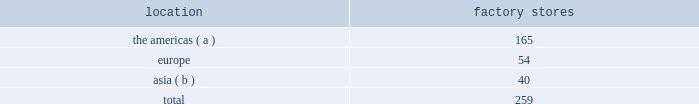Factory stores we extend our reach to additional consumer groups through our 259 factory stores worldwide , which are principally located in major outlet centers .
During fiscal 2015 , we added 30 new factory stores and closed six factory stores .
We operated the following factory stores as of march 28 , 2015: .
( a ) includes the u.s .
And canada .
( b ) includes australia .
Our worldwide factory stores offer selections of our apparel , accessories , and fragrances .
In addition to these product offerings , certain of our factory stores in the americas offer home furnishings .
Our factory stores range in size from approximately 800 to 26700 square feet .
Factory stores obtain products from our suppliers , our product licensing partners , and our other retail stores and e-commerce operations , and also serve as a secondary distribution channel for our excess and out-of-season products .
Concession-based shop-within-shops the terms of trade for shop-within-shops are largely conducted on a concession basis , whereby inventory continues to be owned by us ( not the department store ) until ultimate sale to the end consumer .
The salespeople involved in the sales transactions are generally our employees and not those of the department store .
As of march 28 , 2015 , we had 536 concession-based shop-within-shops at 236 retail locations dedicated to our products , which were located in asia , australia , new zealand , and europe .
The size of our concession-based shop-within-shops ranges from approximately 200 to 6000 square feet .
We may share in the cost of building out certain of these shop-within-shops with our department store partners .
E-commerce websites in addition to our stores , our retail segment sells products online through our e-commerce channel , which includes : 2022 our north american e-commerce sites located at www.ralphlauren.com and www.clubmonaco.com , as well as our club monaco site in canada located at www.clubmonaco.ca ; 2022 our ralph lauren e-commerce sites in europe , including www.ralphlauren.co.uk ( servicing the united kingdom ) , www.ralphlauren.fr ( servicing belgium , france , italy , luxembourg , the netherlands , portugal , and spain ) , and www.ralphlauren.de ( recently expanded to service denmark , estonia , finland , latvia , slovakia , and sweden , in addition to servicing austria and germany ) ; and 2022 our ralph lauren e-commerce sites in asia , including www.ralphlauren.co.jp ( servicing japan ) , www.ralphlauren.co.kr ( servicing south korea ) , www.ralphlauren.asia ( servicing hong kong , macau , malaysia , and singapore ) , and www.ralphlauren.com.au ( servicing australia and new zealand ) .
Our ralph lauren e-commerce sites in the u.s. , europe , and asia offer our customers access to a broad array of ralph lauren , double rl , polo , and denim & supply apparel , accessories , fragrance , and home products , and reinforce the luxury image of our brands .
While investing in e-commerce operations remains a primary focus , it is an extension of our investment in the integrated omni-channel strategy used to operate our overall retail business , in which our e-commerce operations are interdependent with our physical stores .
Our club monaco e-commerce sites in the u.s .
And canada offer our domestic and canadian customers access to our global assortment of club monaco apparel and accessories product lines , as well as select online exclusives. .
What percentage of factory stores as of march 28 , 2015 where located in asia? 
Computations: (40 / 259)
Answer: 0.15444. 